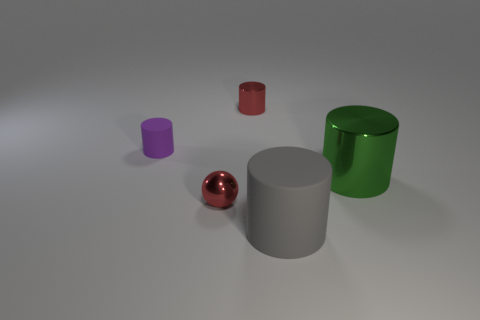Subtract all purple rubber cylinders. How many cylinders are left? 3 Subtract 2 cylinders. How many cylinders are left? 2 Subtract all red cylinders. How many cylinders are left? 3 Add 1 big gray matte spheres. How many objects exist? 6 Subtract all cylinders. How many objects are left? 1 Subtract 0 brown cubes. How many objects are left? 5 Subtract all brown balls. Subtract all gray cylinders. How many balls are left? 1 Subtract all small yellow matte blocks. Subtract all red objects. How many objects are left? 3 Add 4 red cylinders. How many red cylinders are left? 5 Add 3 tiny purple matte cylinders. How many tiny purple matte cylinders exist? 4 